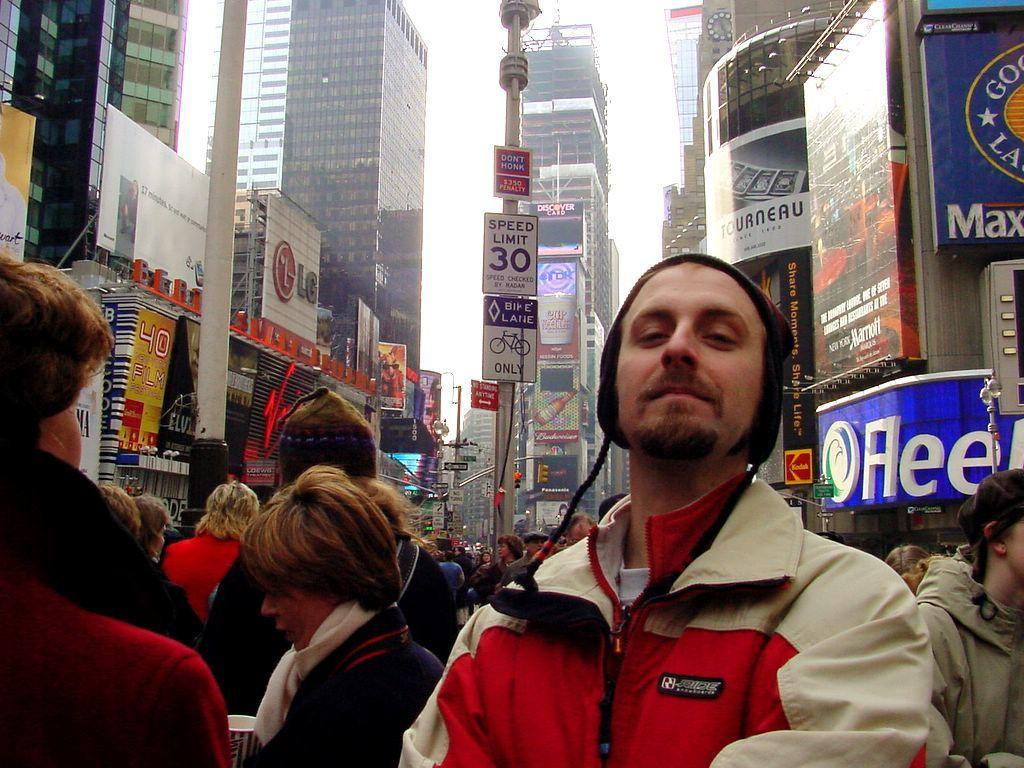<image>
Offer a succinct explanation of the picture presented. Man posing for a photo in front of a side which says the Speed limit is 30. 